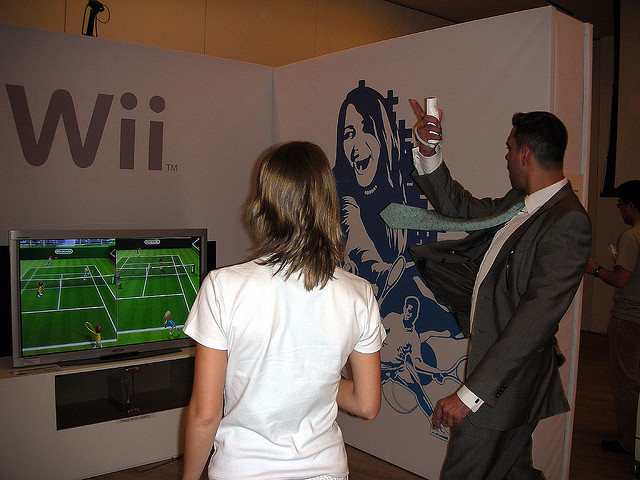Please extract the text content from this image. Wii 